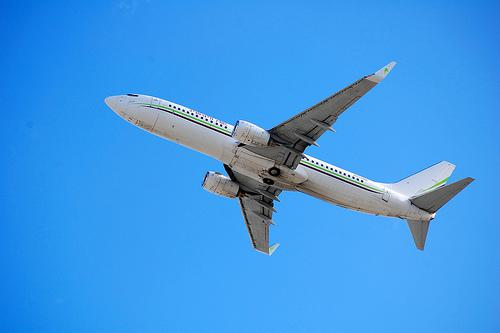What type of vehicle is shown in the image? The image displays a commercial airplane, identifiable by its wings, engines, and distinctive fuselage against the sky. 